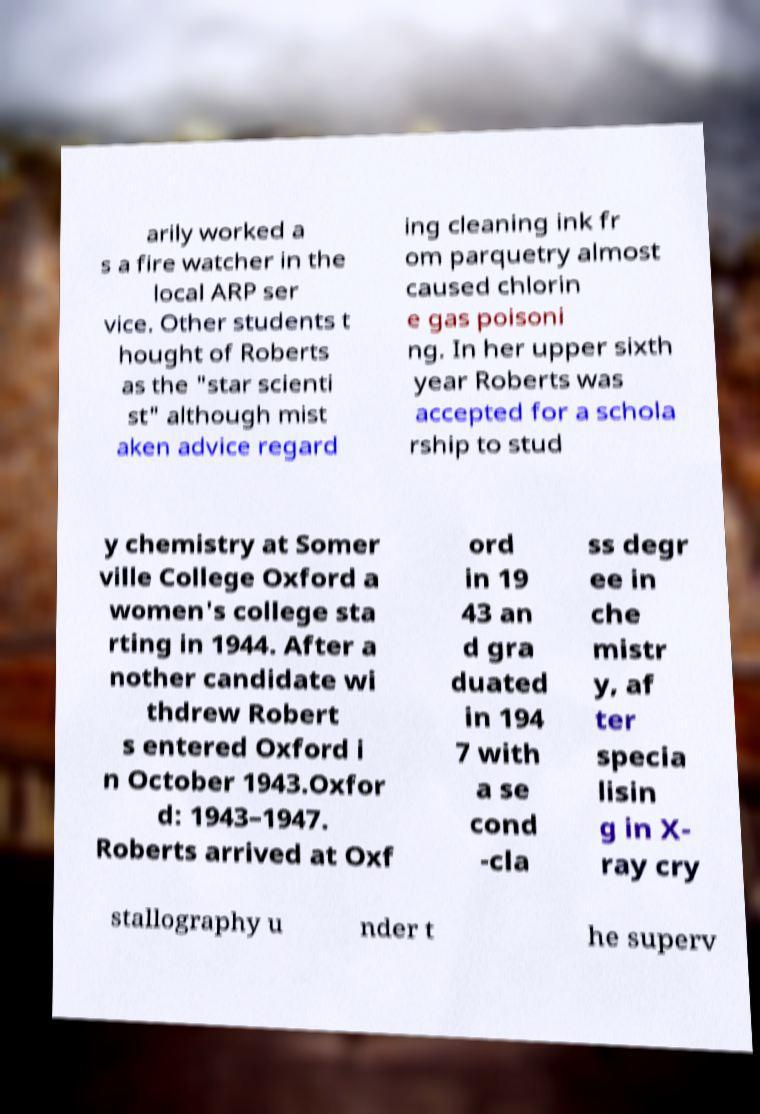What messages or text are displayed in this image? I need them in a readable, typed format. arily worked a s a fire watcher in the local ARP ser vice. Other students t hought of Roberts as the "star scienti st" although mist aken advice regard ing cleaning ink fr om parquetry almost caused chlorin e gas poisoni ng. In her upper sixth year Roberts was accepted for a schola rship to stud y chemistry at Somer ville College Oxford a women's college sta rting in 1944. After a nother candidate wi thdrew Robert s entered Oxford i n October 1943.Oxfor d: 1943–1947. Roberts arrived at Oxf ord in 19 43 an d gra duated in 194 7 with a se cond -cla ss degr ee in che mistr y, af ter specia lisin g in X- ray cry stallography u nder t he superv 